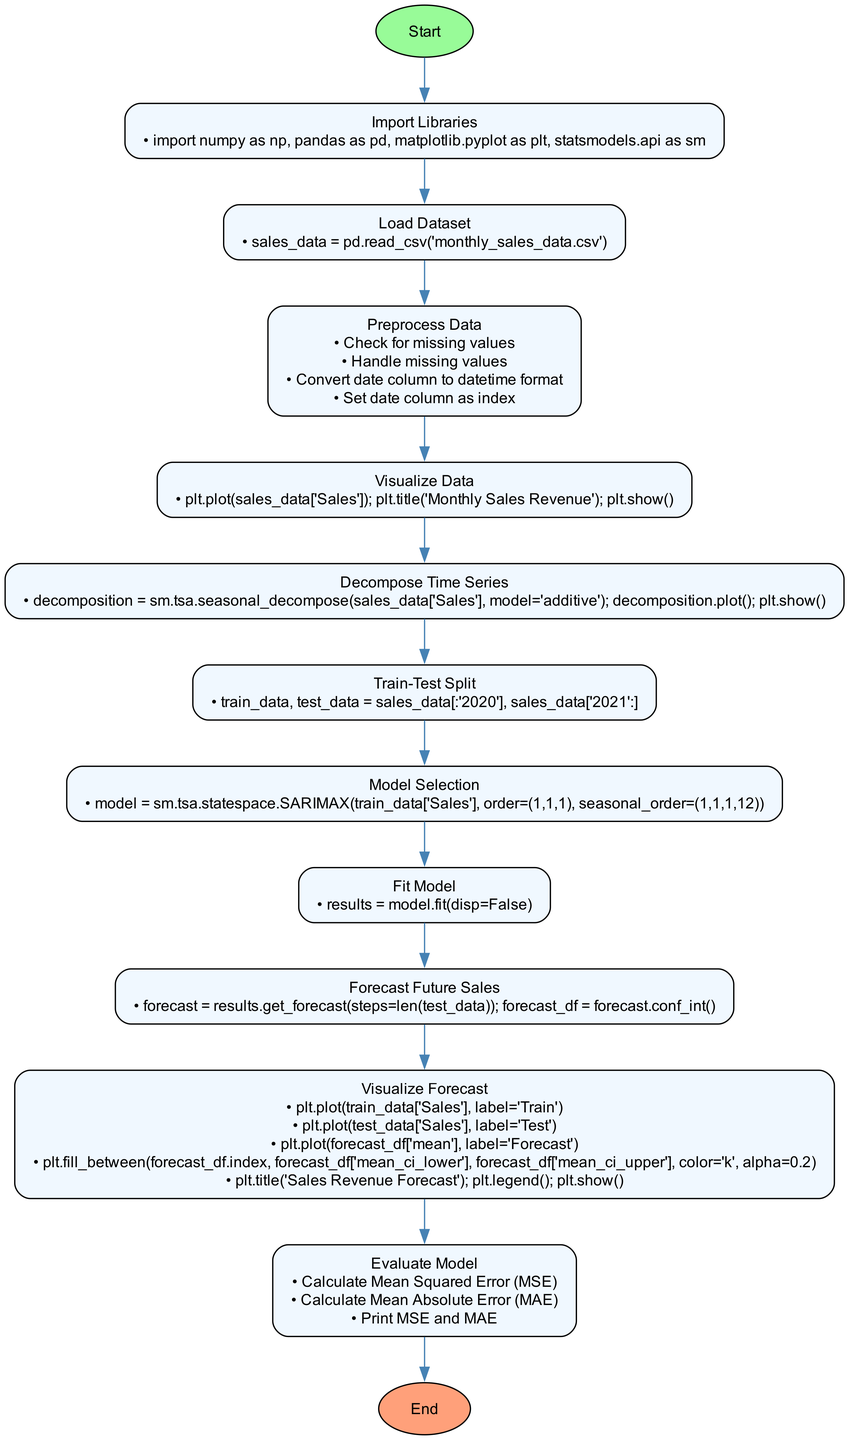What is the first step in the flowchart? The first step is labeled "Import Libraries", showing that the initial action is to import necessary libraries for the analysis.
Answer: Import Libraries How many steps are in the flowchart? By counting the individual actions listed, there are 10 distinct steps in the process before reaching the end.
Answer: 10 What is the action taken in the "Visualize Data" step? The action in this step is to plot the sales data and display a title, indicating a visual representation of sales revenue is created.
Answer: plt.plot(sales_data['Sales']); plt.title('Monthly Sales Revenue'); plt.show() What is being decomposed in the "Decompose Time Series" step? The "Sales" data from the dataset is being decomposed in this step to identify its seasonal and trend components.
Answer: Sales Which step follows "Evaluate Model"? After evaluating the model, the flowchart proceeds to the endpoint labeled "End", indicating that the process is complete.
Answer: End What is the purpose of the "Train-Test Split" step? This step separates the dataset into training and testing subsets, which is crucial for validating the model's performance on unseen data.
Answer: Train-Test Split What type of model is selected in the "Model Selection" step? The model selected is a SARIMAX model, which is specifically designed for seasonal time series forecasting.
Answer: SARIMAX What does the "Forecast Future Sales" step produce? This step generates a forecast for future sales based on the fitted model, providing predictions for the specified test data period.
Answer: forecast What evaluation metrics are calculated in the "Evaluate Model" step? The model evaluation includes calculating the Mean Squared Error (MSE) and Mean Absolute Error (MAE) to assess the prediction accuracy.
Answer: MSE and MAE 